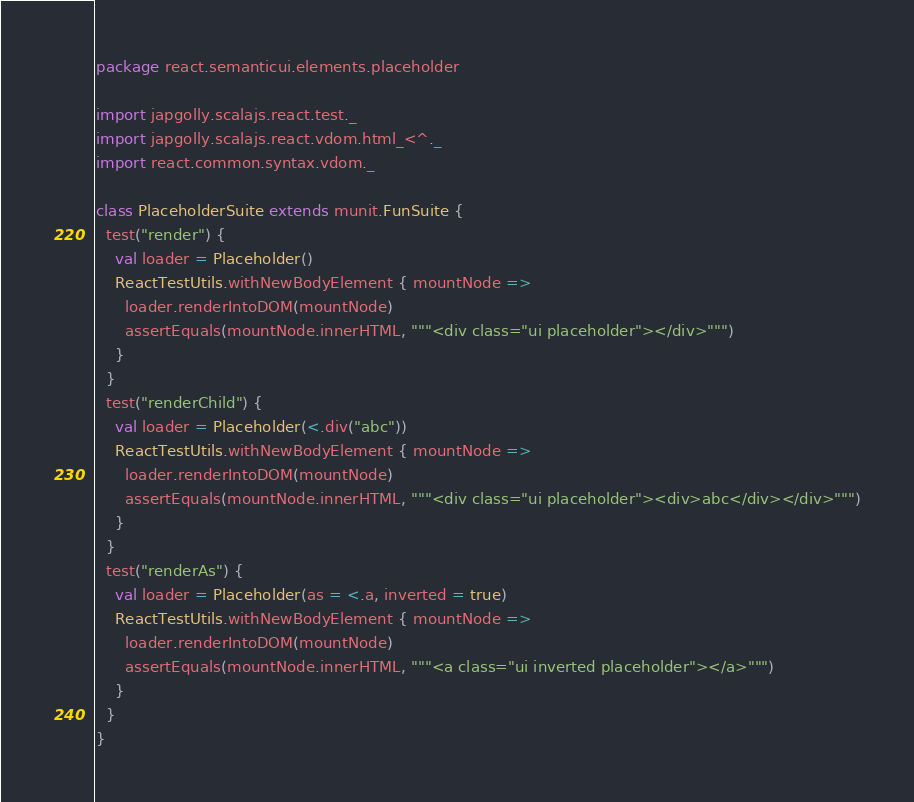<code> <loc_0><loc_0><loc_500><loc_500><_Scala_>package react.semanticui.elements.placeholder

import japgolly.scalajs.react.test._
import japgolly.scalajs.react.vdom.html_<^._
import react.common.syntax.vdom._

class PlaceholderSuite extends munit.FunSuite {
  test("render") {
    val loader = Placeholder()
    ReactTestUtils.withNewBodyElement { mountNode =>
      loader.renderIntoDOM(mountNode)
      assertEquals(mountNode.innerHTML, """<div class="ui placeholder"></div>""")
    }
  }
  test("renderChild") {
    val loader = Placeholder(<.div("abc"))
    ReactTestUtils.withNewBodyElement { mountNode =>
      loader.renderIntoDOM(mountNode)
      assertEquals(mountNode.innerHTML, """<div class="ui placeholder"><div>abc</div></div>""")
    }
  }
  test("renderAs") {
    val loader = Placeholder(as = <.a, inverted = true)
    ReactTestUtils.withNewBodyElement { mountNode =>
      loader.renderIntoDOM(mountNode)
      assertEquals(mountNode.innerHTML, """<a class="ui inverted placeholder"></a>""")
    }
  }
}
</code> 